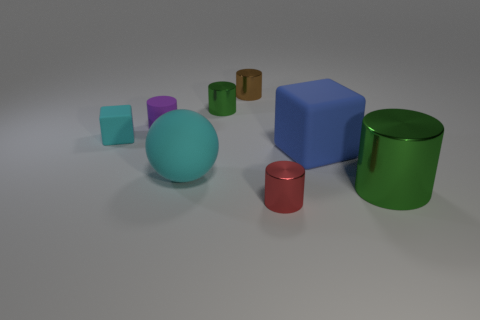Subtract all matte cylinders. How many cylinders are left? 4 Add 1 large brown matte cylinders. How many objects exist? 9 Subtract all brown cylinders. How many cylinders are left? 4 Subtract all blocks. How many objects are left? 6 Subtract all gray balls. How many green cylinders are left? 2 Subtract all large cyan shiny objects. Subtract all cylinders. How many objects are left? 3 Add 7 blue rubber objects. How many blue rubber objects are left? 8 Add 3 big green metal objects. How many big green metal objects exist? 4 Subtract 0 purple balls. How many objects are left? 8 Subtract all red cubes. Subtract all yellow cylinders. How many cubes are left? 2 